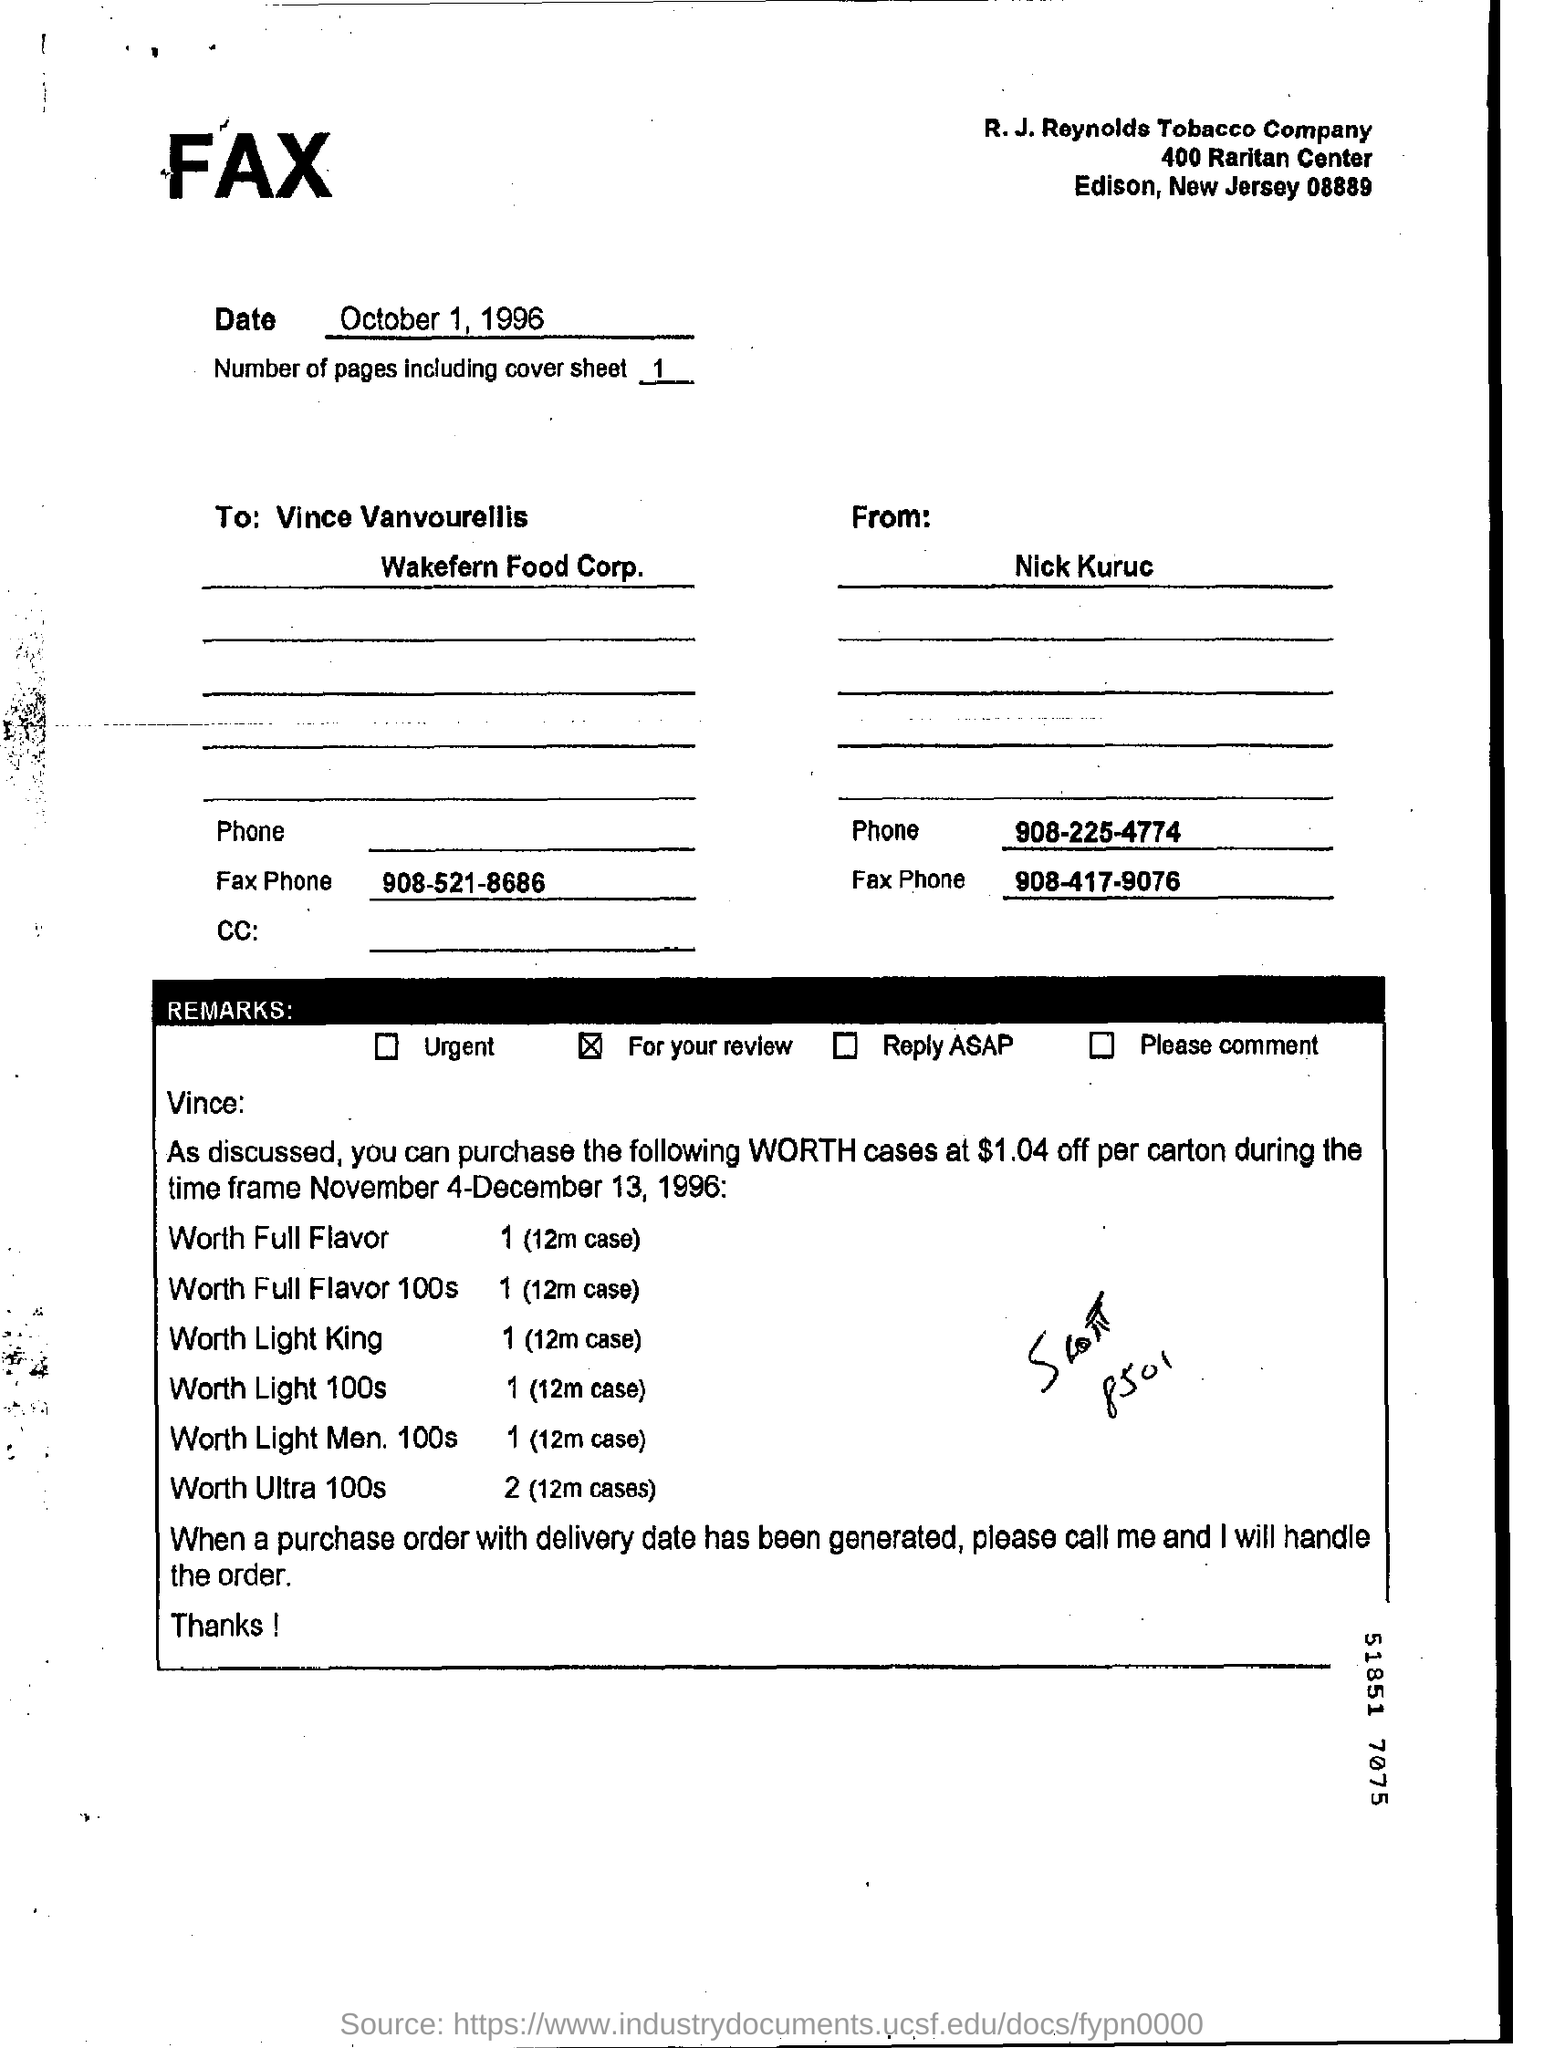Draw attention to some important aspects in this diagram. The document was faxed on October 1, 1996. Under the Remarks section, the marked option is present. The remark item that has been marked is highlighted for your review. The document was transmitted by fax and the person who sent it is named Nick Kuruc. 